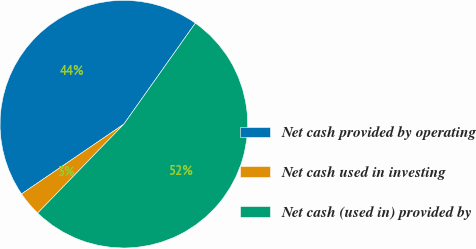Convert chart. <chart><loc_0><loc_0><loc_500><loc_500><pie_chart><fcel>Net cash provided by operating<fcel>Net cash used in investing<fcel>Net cash (used in) provided by<nl><fcel>44.33%<fcel>3.22%<fcel>52.45%<nl></chart> 